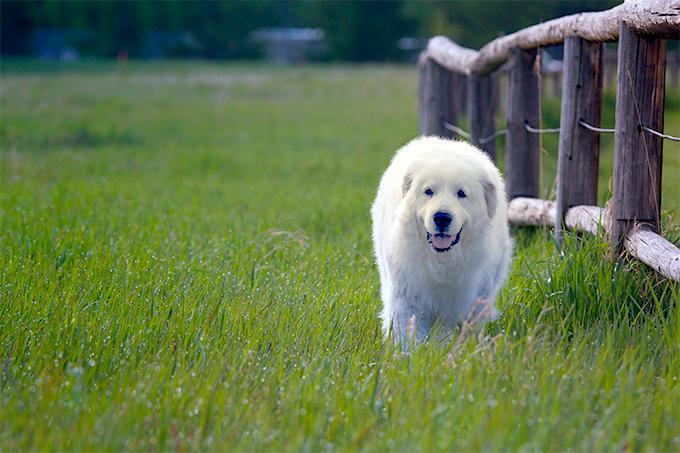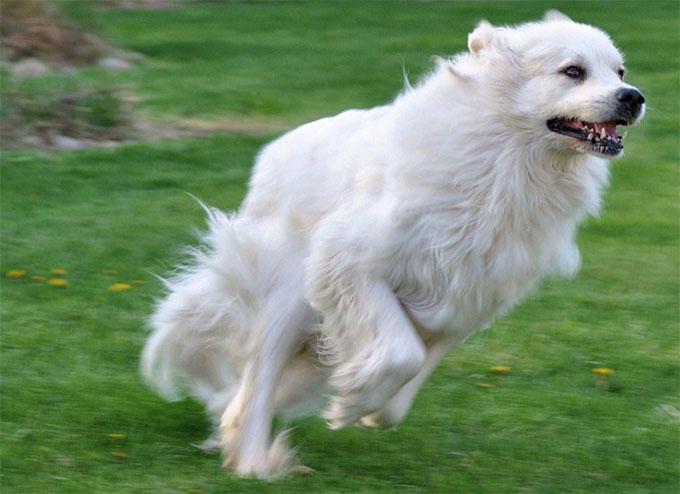The first image is the image on the left, the second image is the image on the right. Evaluate the accuracy of this statement regarding the images: "The left image shows a white dog in the grass.". Is it true? Answer yes or no. Yes. 